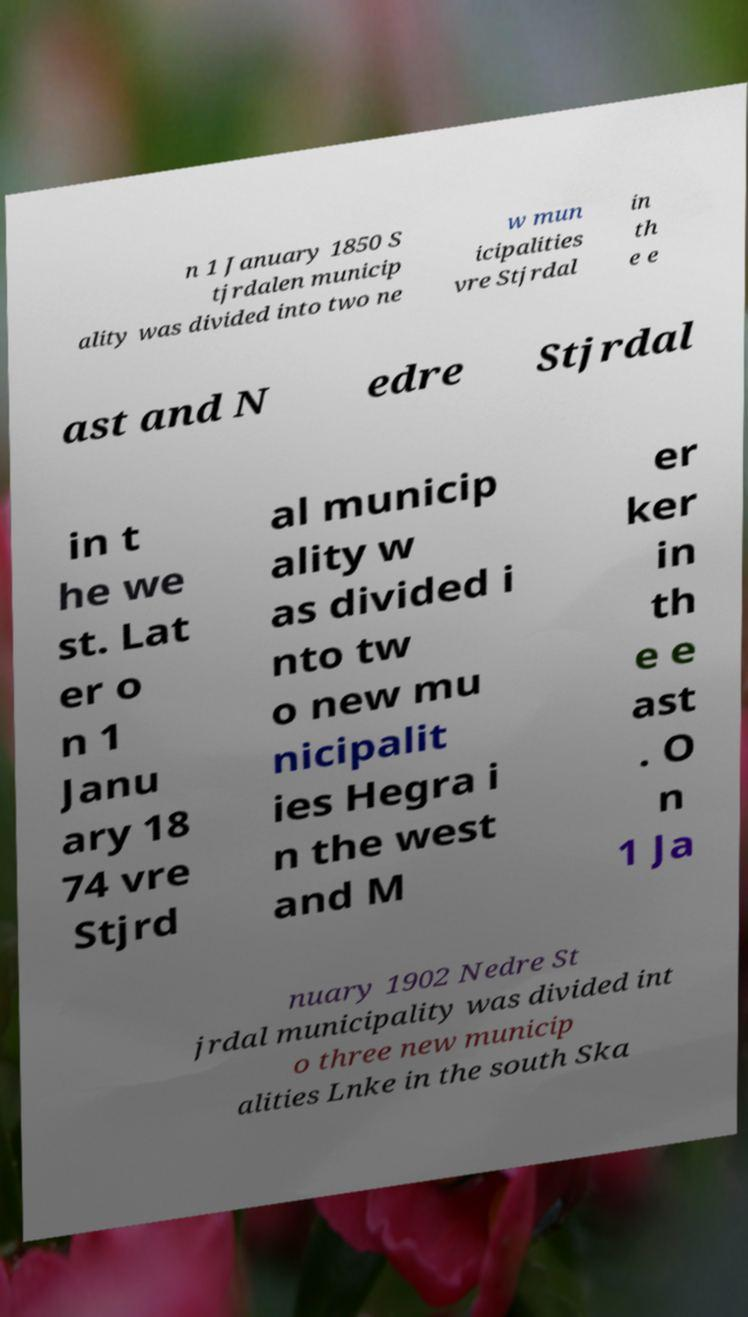Could you assist in decoding the text presented in this image and type it out clearly? n 1 January 1850 S tjrdalen municip ality was divided into two ne w mun icipalities vre Stjrdal in th e e ast and N edre Stjrdal in t he we st. Lat er o n 1 Janu ary 18 74 vre Stjrd al municip ality w as divided i nto tw o new mu nicipalit ies Hegra i n the west and M er ker in th e e ast . O n 1 Ja nuary 1902 Nedre St jrdal municipality was divided int o three new municip alities Lnke in the south Ska 